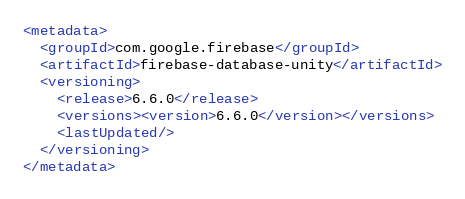<code> <loc_0><loc_0><loc_500><loc_500><_XML_><metadata>
  <groupId>com.google.firebase</groupId>
  <artifactId>firebase-database-unity</artifactId>
  <versioning>
    <release>6.6.0</release>
    <versions><version>6.6.0</version></versions>
    <lastUpdated/>
  </versioning>
</metadata>

</code> 